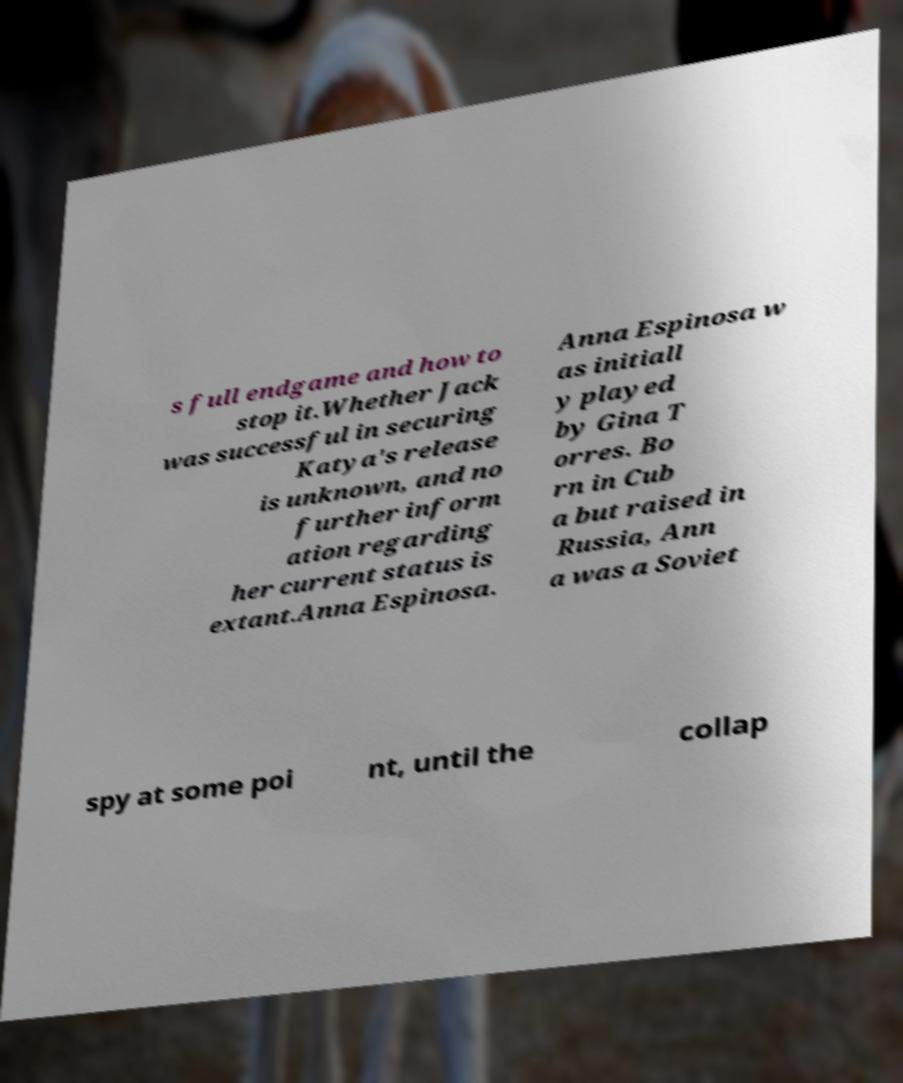Please read and relay the text visible in this image. What does it say? s full endgame and how to stop it.Whether Jack was successful in securing Katya's release is unknown, and no further inform ation regarding her current status is extant.Anna Espinosa. Anna Espinosa w as initiall y played by Gina T orres. Bo rn in Cub a but raised in Russia, Ann a was a Soviet spy at some poi nt, until the collap 